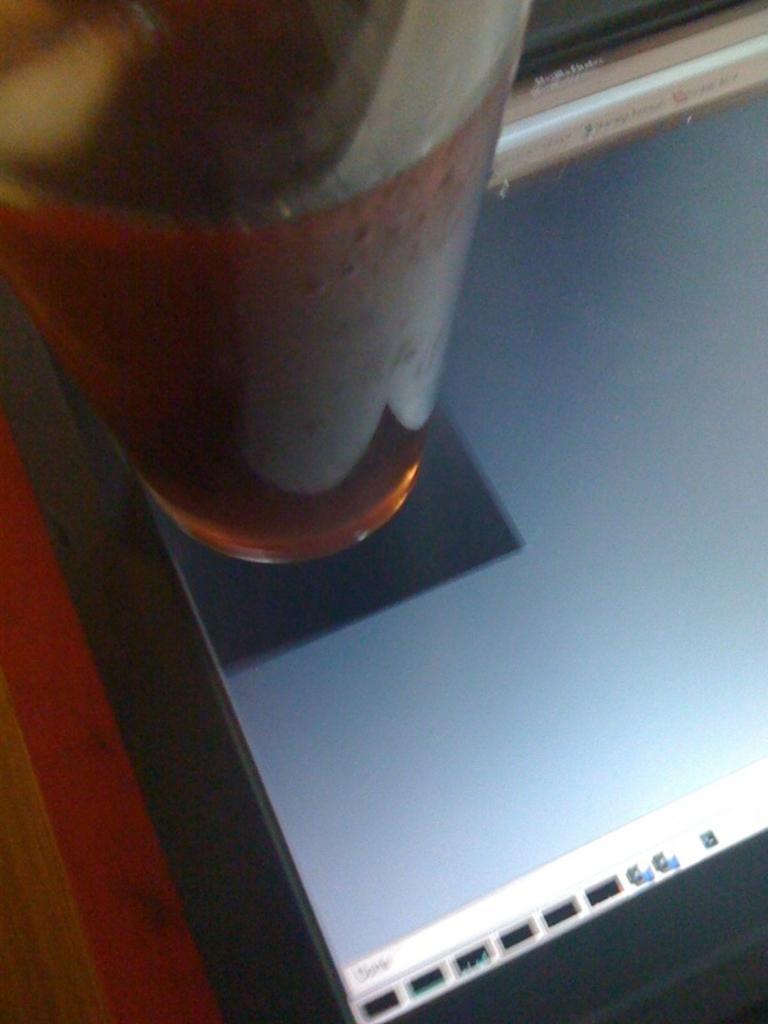Can you describe this image briefly? In this image we can see a glass and a screen of a laptop. 